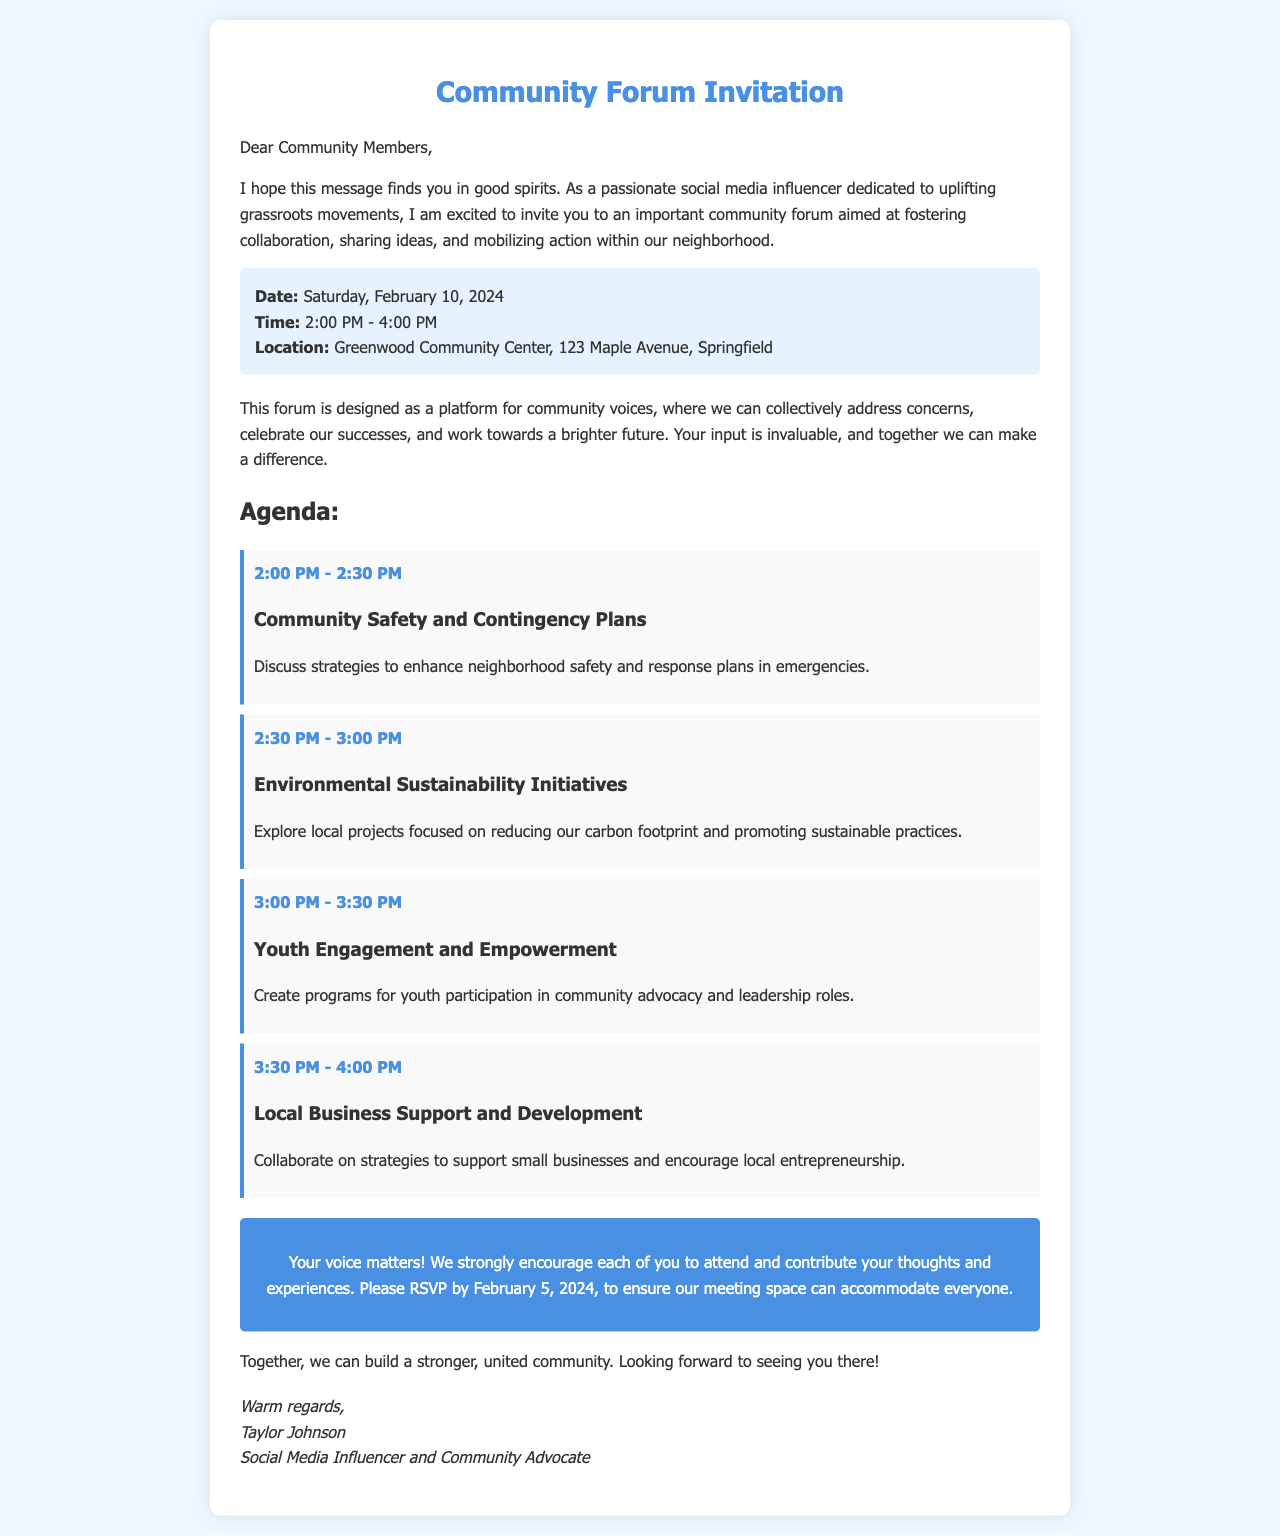What is the date of the community forum? The date of the community forum is specified in the document as Saturday, February 10, 2024.
Answer: Saturday, February 10, 2024 What is the location of the event? The document provides the location as Greenwood Community Center, 123 Maple Avenue, Springfield.
Answer: Greenwood Community Center, 123 Maple Avenue, Springfield How long is the community forum scheduled to last? The forum starts at 2:00 PM and ends at 4:00 PM, indicating it lasts for 2 hours.
Answer: 2 hours What is one of the agenda topics related to youth? The agenda includes a topic for discussing Youth Engagement and Empowerment related to the participation of youth in advocacy.
Answer: Youth Engagement and Empowerment What is the call to action regarding RSVPs? The document mentions that attendees should RSVP by February 5, 2024, to accommodate everyone.
Answer: February 5, 2024 Who is the author of the invitation letter? The author of the letter is identified as Taylor Johnson in the signature at the end.
Answer: Taylor Johnson What time does the discussion on Environmental Sustainability Initiatives start? The document specifies that this topic starts at 2:30 PM.
Answer: 2:30 PM What is a main goal of the community forum? The document states that a main goal is to foster collaboration among community members.
Answer: Foster collaboration What type of event is being organized? The document describes the event as a community forum.
Answer: Community forum 